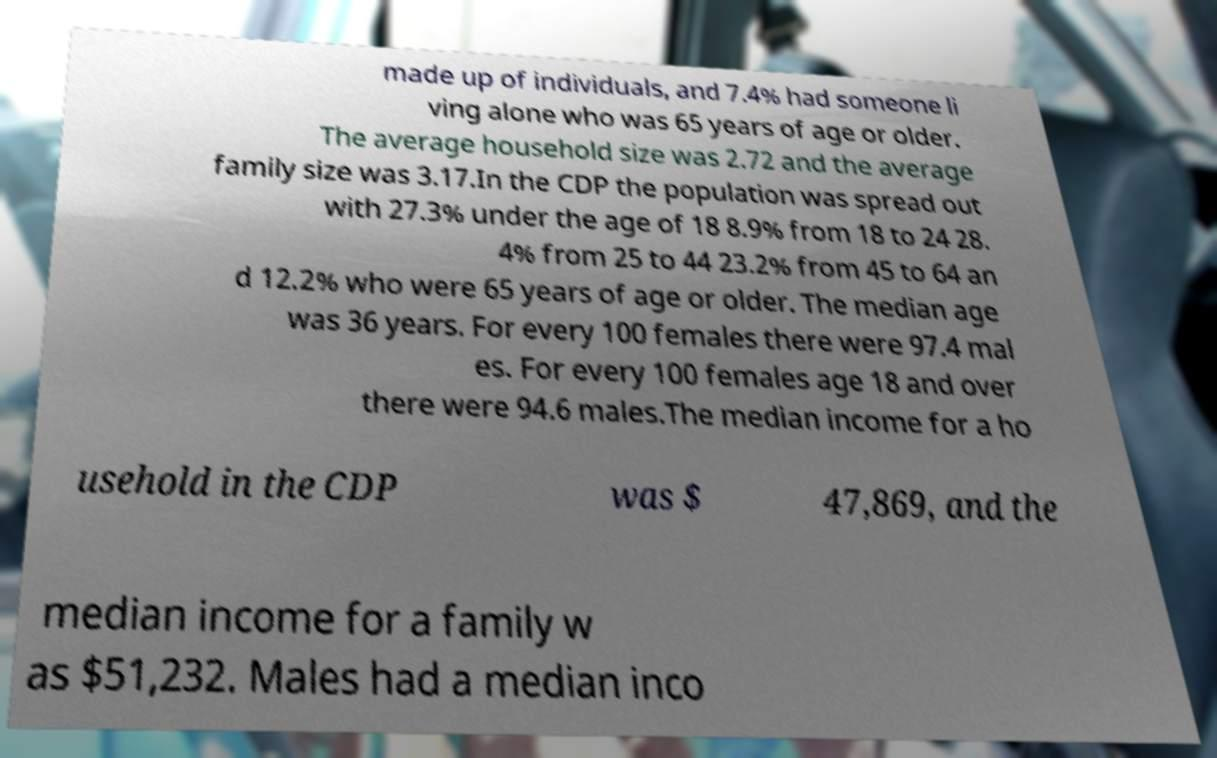Can you read and provide the text displayed in the image?This photo seems to have some interesting text. Can you extract and type it out for me? made up of individuals, and 7.4% had someone li ving alone who was 65 years of age or older. The average household size was 2.72 and the average family size was 3.17.In the CDP the population was spread out with 27.3% under the age of 18 8.9% from 18 to 24 28. 4% from 25 to 44 23.2% from 45 to 64 an d 12.2% who were 65 years of age or older. The median age was 36 years. For every 100 females there were 97.4 mal es. For every 100 females age 18 and over there were 94.6 males.The median income for a ho usehold in the CDP was $ 47,869, and the median income for a family w as $51,232. Males had a median inco 